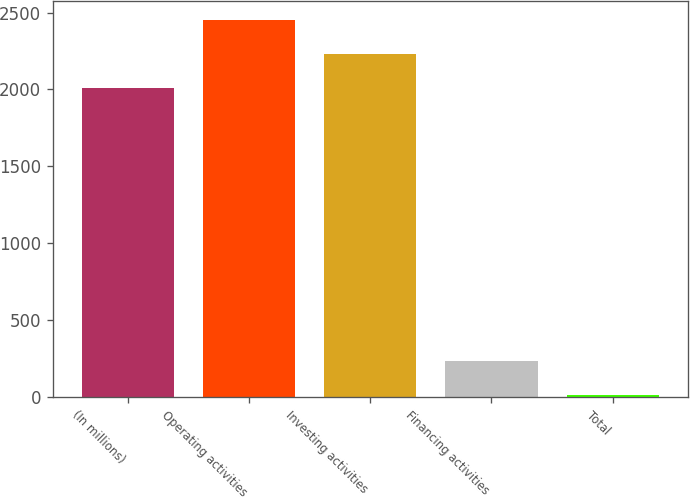<chart> <loc_0><loc_0><loc_500><loc_500><bar_chart><fcel>(In millions)<fcel>Operating activities<fcel>Investing activities<fcel>Financing activities<fcel>Total<nl><fcel>2010<fcel>2451.4<fcel>2230.7<fcel>230.7<fcel>10<nl></chart> 